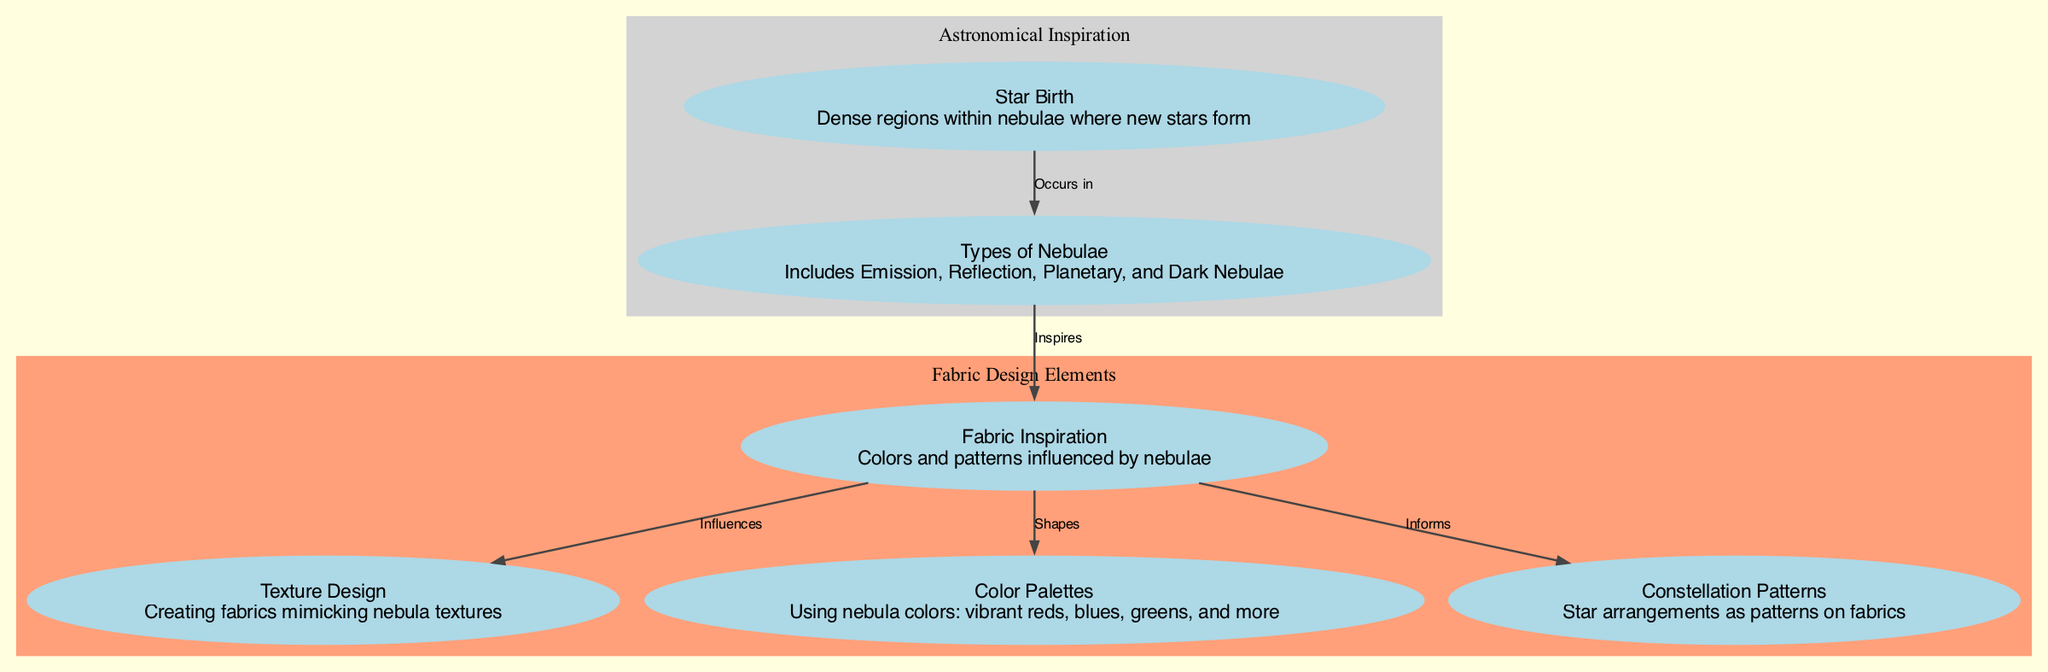What is the label of the node that describes "Dense regions within nebulae where new stars form"? The label for that node is "Star Birth." By locating the specific node mentioned in the diagram and reading its description, we can directly identify it as the one that corresponds to the term given in the question.
Answer: Star Birth How many types of nebulae are mentioned? The diagram specifies that there are four types of nebulae: Emission, Reflection, Planetary, and Dark Nebulae. Counting these types from the "Types of Nebulae" node provides the answer.
Answer: 4 What influences the creation of fabrics that mimic nebula textures? The "Fabric Inspiration" node indicates that it influences "Texture Design," pointing out the relationship between how nebulae inspire the creation of fabric textures. Therefore, the answer lies in understanding this direct influence connection.
Answer: Fabric Inspiration Which node informs the designs of star arrangements on fabrics? The node that informs such designs is "Fabric Inspiration," which links to "Constellation Patterns." Thus, by examining the edges from "Fabric Inspiration," we can conclude that it plays a key role in informing these designs.
Answer: Fabric Inspiration What is the connection between nebula types and star birth? The connection shown in the diagram indicates that star birth occurs in areas characterized by different types of nebulae, as highlighted by the edge labeled "Occurs in" connecting "Star Birth" to "Types of Nebulae."
Answer: Occurs in What does "Fabric Inspiration" shape in the context of material design? According to the diagram, "Fabric Inspiration" shapes the "Color Palettes." By looking at the edges branching out from "Fabric Inspiration," it is evident that it has a significant impact on determining the color choices in fabric design.
Answer: Color Palettes Which node represents the textures that are mimicked in fabric design? The node that represents the textures being mimicked is "Texture Design." This can be directly identified by locating the node that describes fabric creation based on nebula textures and looking at the edges for verification.
Answer: Texture Design How many edges are depicted in the diagram? The diagram features six edges, which can be counted by examining the connections established between various nodes detailed in the edges section of the diagram.
Answer: 6 What colors are included in the color palettes inspired by nebulae? The color palettes include vibrant reds, blues, greens, and more, as indicated in the description associated with the "Color Palettes" node. This detail uncovers the variety of colors that are drawn from nebulae for design purposes.
Answer: Reds, blues, greens, and more 